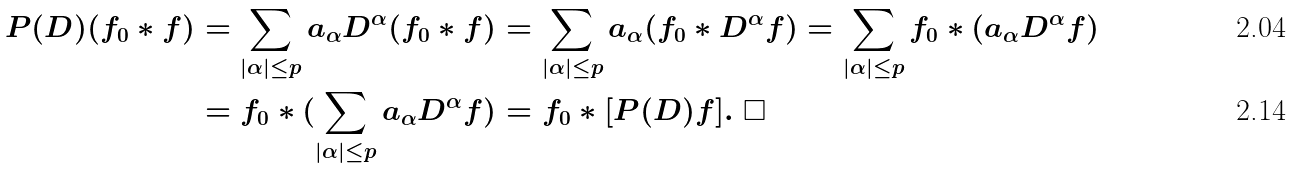Convert formula to latex. <formula><loc_0><loc_0><loc_500><loc_500>P ( D ) ( f _ { 0 } \ast f ) & = \sum _ { | \alpha | \leq p } a _ { \alpha } D ^ { \alpha } ( f _ { 0 } \ast f ) = \sum _ { | \alpha | \leq p } a _ { \alpha } ( f _ { 0 } \ast D ^ { \alpha } f ) = \sum _ { | \alpha | \leq p } f _ { 0 } \ast ( a _ { \alpha } D ^ { \alpha } f ) \\ & = f _ { 0 } \ast ( \sum _ { | \alpha | \leq p } a _ { \alpha } D ^ { \alpha } f ) = f _ { 0 } \ast [ P ( D ) f ] . \ \square</formula> 